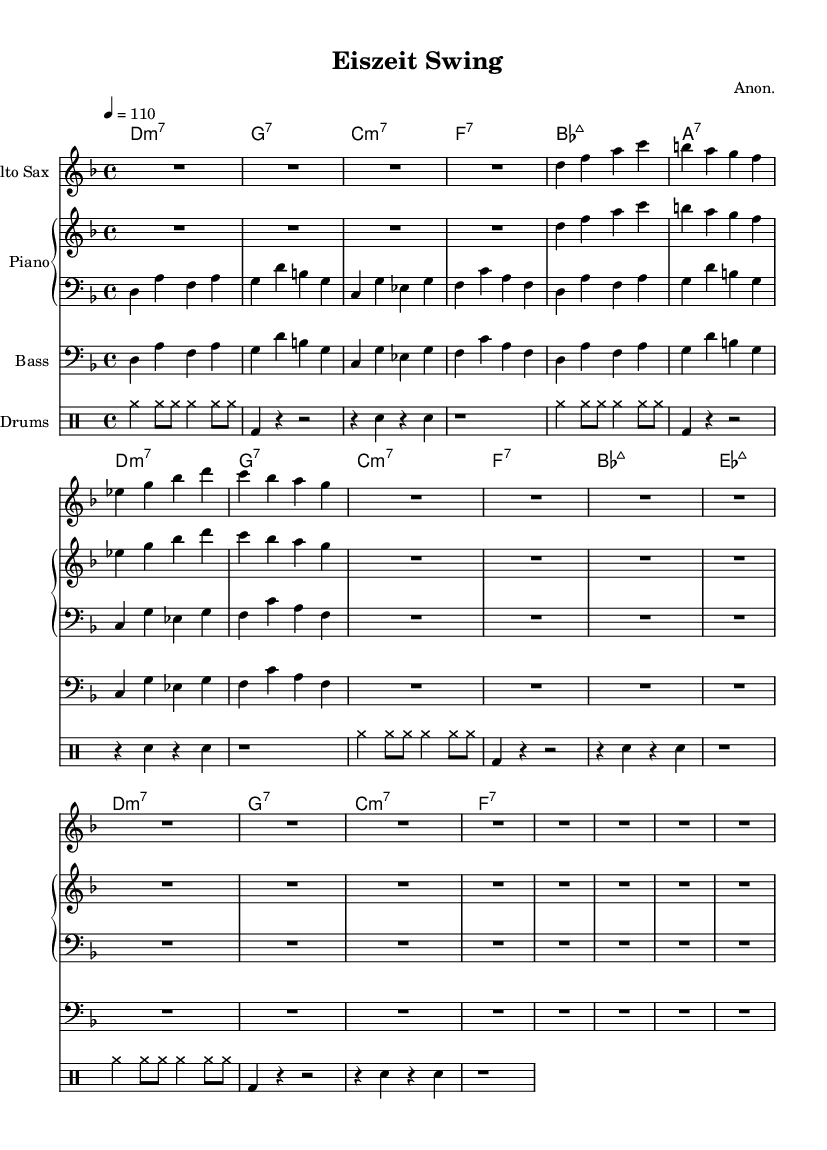What is the key signature of this music? The key signature is indicated at the beginning of the sheet music with the symbol for D minor, which has one flat (B flat).
Answer: D minor What is the time signature of this music? The time signature is present at the beginning and shown as 4/4, indicating four beats per measure with a quarter note getting one beat.
Answer: 4/4 What is the tempo marking for this piece? The tempo is indicated at the top as “4 = 110”, meaning that there are 110 beats per minute, and the quarter note equals one beat.
Answer: 110 How many measures of rest are given in the saxophone music? By examining the saxophone part, there is 1 measure of rest followed by 12 measures of rest after the initial four measures of music, totalling to 13 measures.
Answer: 13 Which instruments are included in this composition? The composition includes Alto Sax, Piano (both right and left hand), Bass, and Drums, which can be identified by the instrument names above each staff in the sheet music.
Answer: Alto Sax, Piano, Bass, Drums What is the chord progression for the first four measures? The chord names provided at the beginning indicate that the first four measures feature D minor 7, G7, C minor 7, and F7, providing a structured harmonic foundation for the melody.
Answer: D minor 7, G7, C minor 7, F7 How many times is the chord E flat major 7 played in this piece? The chord E flat major 7 is played specifically once in the 9th measure, as shown in the chord names section, confirming its singular occurrence in the harmonic structure.
Answer: 1 